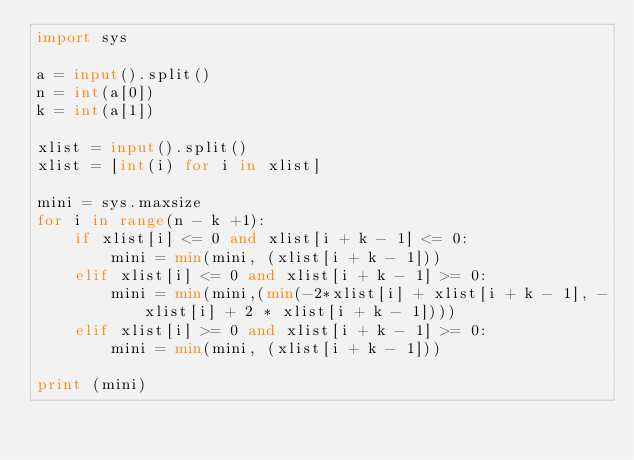Convert code to text. <code><loc_0><loc_0><loc_500><loc_500><_Python_>import sys

a = input().split()
n = int(a[0])
k = int(a[1])

xlist = input().split()
xlist = [int(i) for i in xlist]

mini = sys.maxsize
for i in range(n - k +1):
	if xlist[i] <= 0 and xlist[i + k - 1] <= 0:
		mini = min(mini, (xlist[i + k - 1]))
	elif xlist[i] <= 0 and xlist[i + k - 1] >= 0:
		mini = min(mini,(min(-2*xlist[i] + xlist[i + k - 1], -xlist[i] + 2 * xlist[i + k - 1])))
	elif xlist[i] >= 0 and xlist[i + k - 1] >= 0:
		mini = min(mini, (xlist[i + k - 1]))
		
print (mini)</code> 